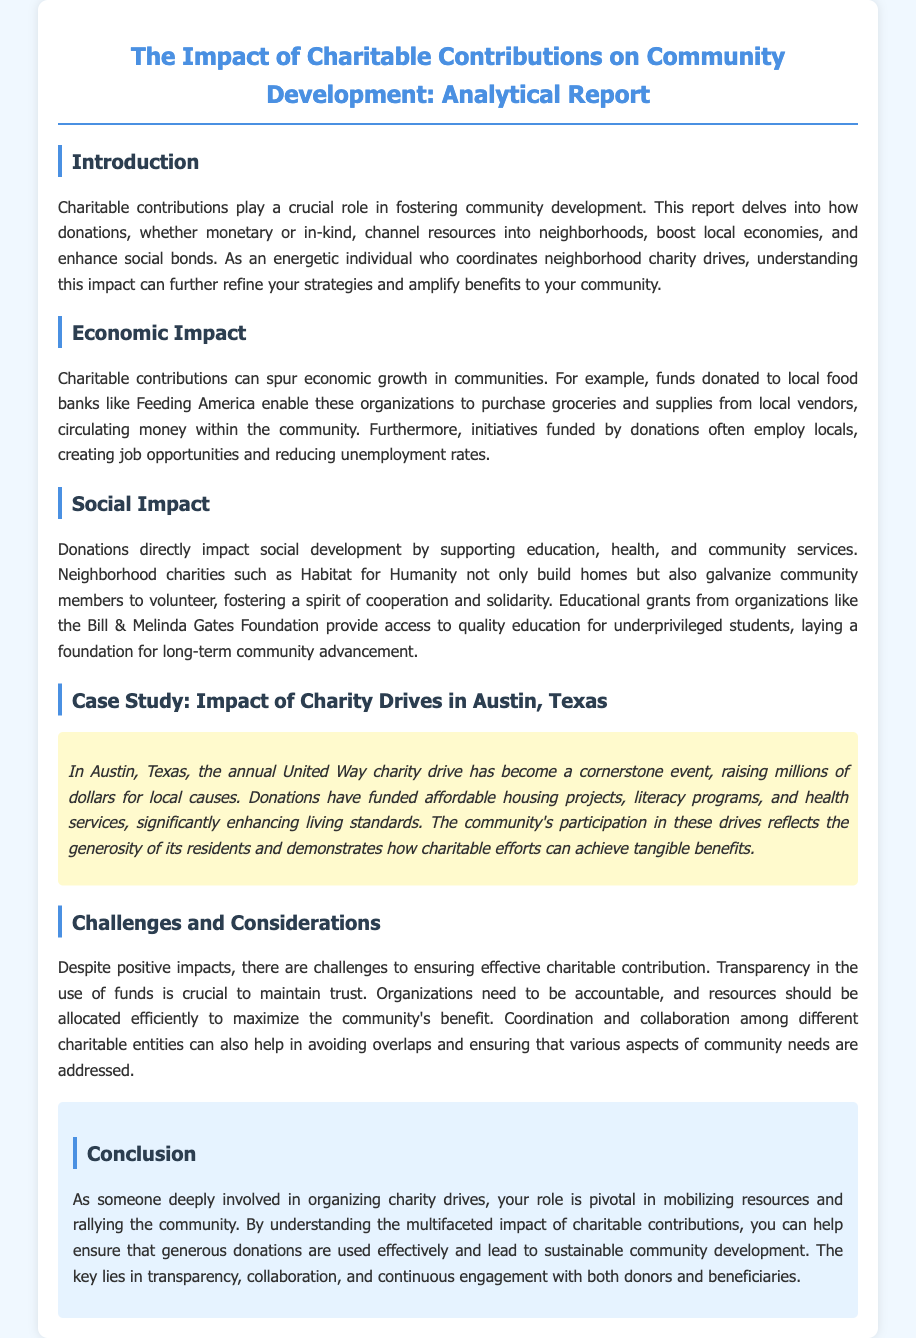what is the title of the report? The title of the report is prominently displayed at the top of the document.
Answer: The Impact of Charitable Contributions on Community Development: Analytical Report which organization is mentioned as an example of local food banks? The document provides an example of a local food bank that benefits from charitable contributions.
Answer: Feeding America what type of initiatives do donations enable in local vendors? The report discusses the economic benefits gained from charitable donations directed at local businesses.
Answer: Purchasing groceries and supplies which foundation is noted for providing educational grants? The document mentions a specific organization that supports education through funding.
Answer: Bill & Melinda Gates Foundation what event is highlighted as a cornerstone in Austin, Texas? A specific charity drive in Austin is referenced as significant to the community.
Answer: United Way charity drive what is a crucial factor for maintaining trust in charitable organizations? The document lists an essential element that helps maintain public confidence in charitable actions.
Answer: Transparency what are considered challenges in charitable contributions? The report outlines several specific issues that can hinder the effectiveness of donations.
Answer: Transparency and accountability which social development area is impacted by donations? The document highlights several sectors that benefit from charitable contributions.
Answer: Education what should be ensured for sustainable community development? The conclusion summarizes what is necessary for the effective use of charitable contributions.
Answer: Transparency, collaboration, and continuous engagement 